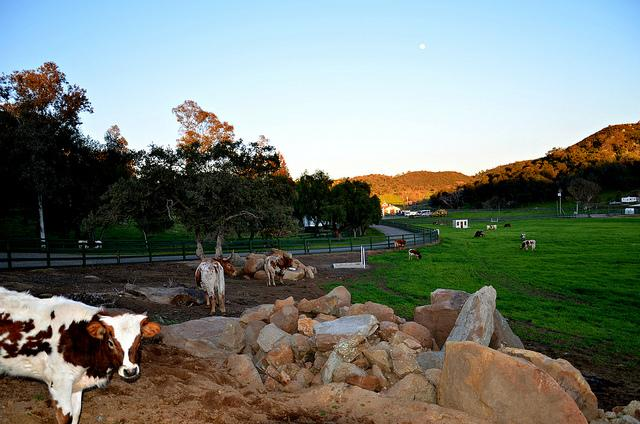What colors are on the cow closest to the camera?

Choices:
A) orange
B) blue
C) brown white
D) black brown white 